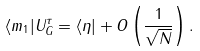<formula> <loc_0><loc_0><loc_500><loc_500>\langle m _ { 1 } | U _ { G } ^ { \tau } = \langle \eta | + O \left ( \frac { 1 } { \sqrt { N } } \right ) .</formula> 